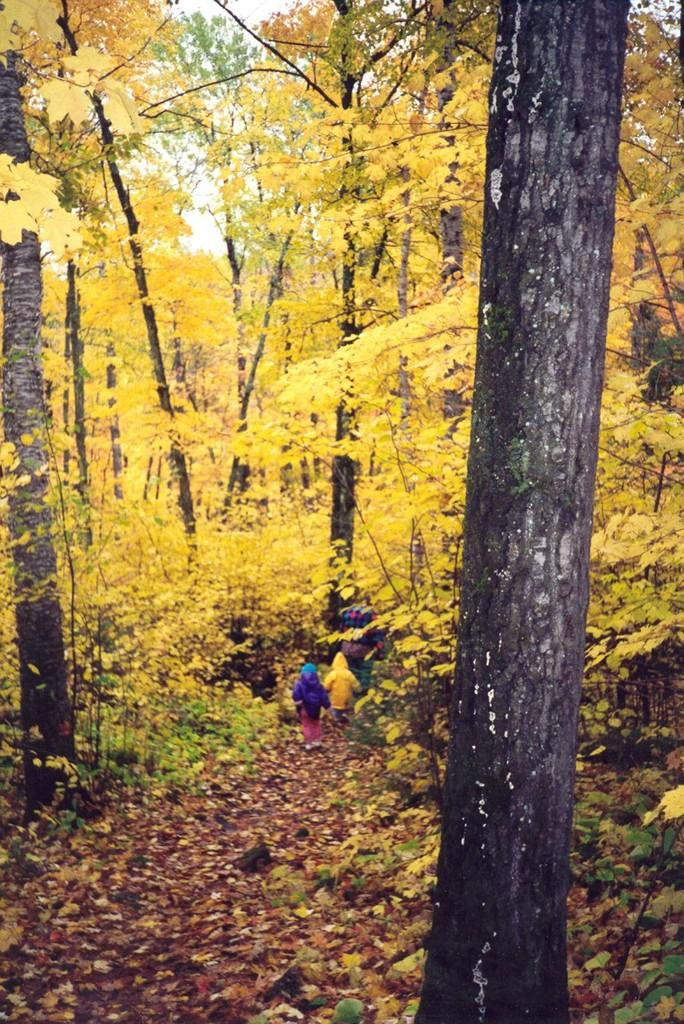What can be seen in the foreground of the image? There are trees and two persons in the foreground of the image. What is visible in the background of the image? The sky is visible in the image. Based on the time of day when the image was likely taken, what can be inferred about the lighting conditions? The image may have been taken during the day, so the lighting conditions would be bright and natural. What type of environment might the image have been taken in? The image may have been taken in a forest, given the presence of trees in the foreground. What type of jail can be seen in the image? There is no jail present in the image; it features trees and two persons in the foreground. What kind of boot is being worn by the person on the left in the image? There is no information about the footwear of the persons in the image, as the focus is on the trees and the overall environment. 